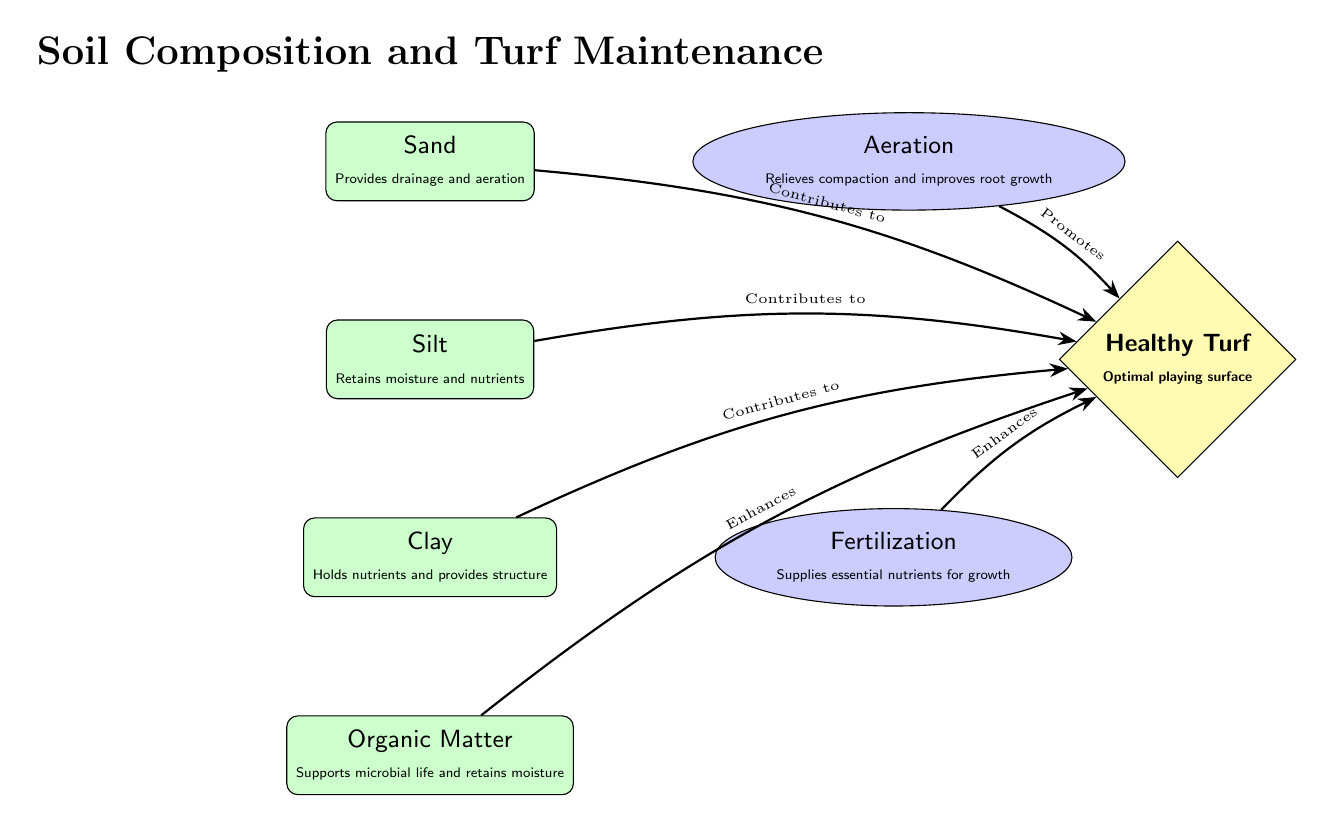What is the top component of soil in the diagram? The diagram lists sand as the top component of soil. This can be determined by looking at the order in which the components are organized vertically, with sand appearing at the top.
Answer: Sand How many components are listed in the soil section? There are four components listed in the soil section: sand, silt, clay, and organic matter. This can be counted as they are organized vertically one below the other.
Answer: 4 What technique is represented on the right of sand? The technique represented on the right of sand is aeration. This can be found by looking directly to the right of the sand node.
Answer: Aeration Which node enhances healthy turf? The organic matter node is indicated to enhance healthy turf. This can be verified by examining the arrows that indicate contributions to the outcome node.
Answer: Organic Matter What two maintenance techniques are mentioned? The two maintenance techniques mentioned are aeration and fertilization. These can be identified as they are displayed as maintenance techniques on the right side of the soil components.
Answer: Aeration, Fertilization How does silt contribute to healthy turf? Silt contributes to healthy turf by retaining moisture and nutrients. This information is provided below the silt component in the diagram.
Answer: Retains moisture and nutrients Which component holds nutrients and provides structure? The component that holds nutrients and provides structure is clay. This can be confirmed by reviewing the description next to the clay node.
Answer: Clay What is the outcome of proper soil composition and maintenance techniques? The outcome of proper soil composition and maintenance techniques is healthy turf. This is the final result indicated by the outcome node on the diagram.
Answer: Healthy Turf Which soil component is primarily responsible for drainage? The soil component primarily responsible for drainage is sand. This is stated in the description accompanying the sand node.
Answer: Sand 